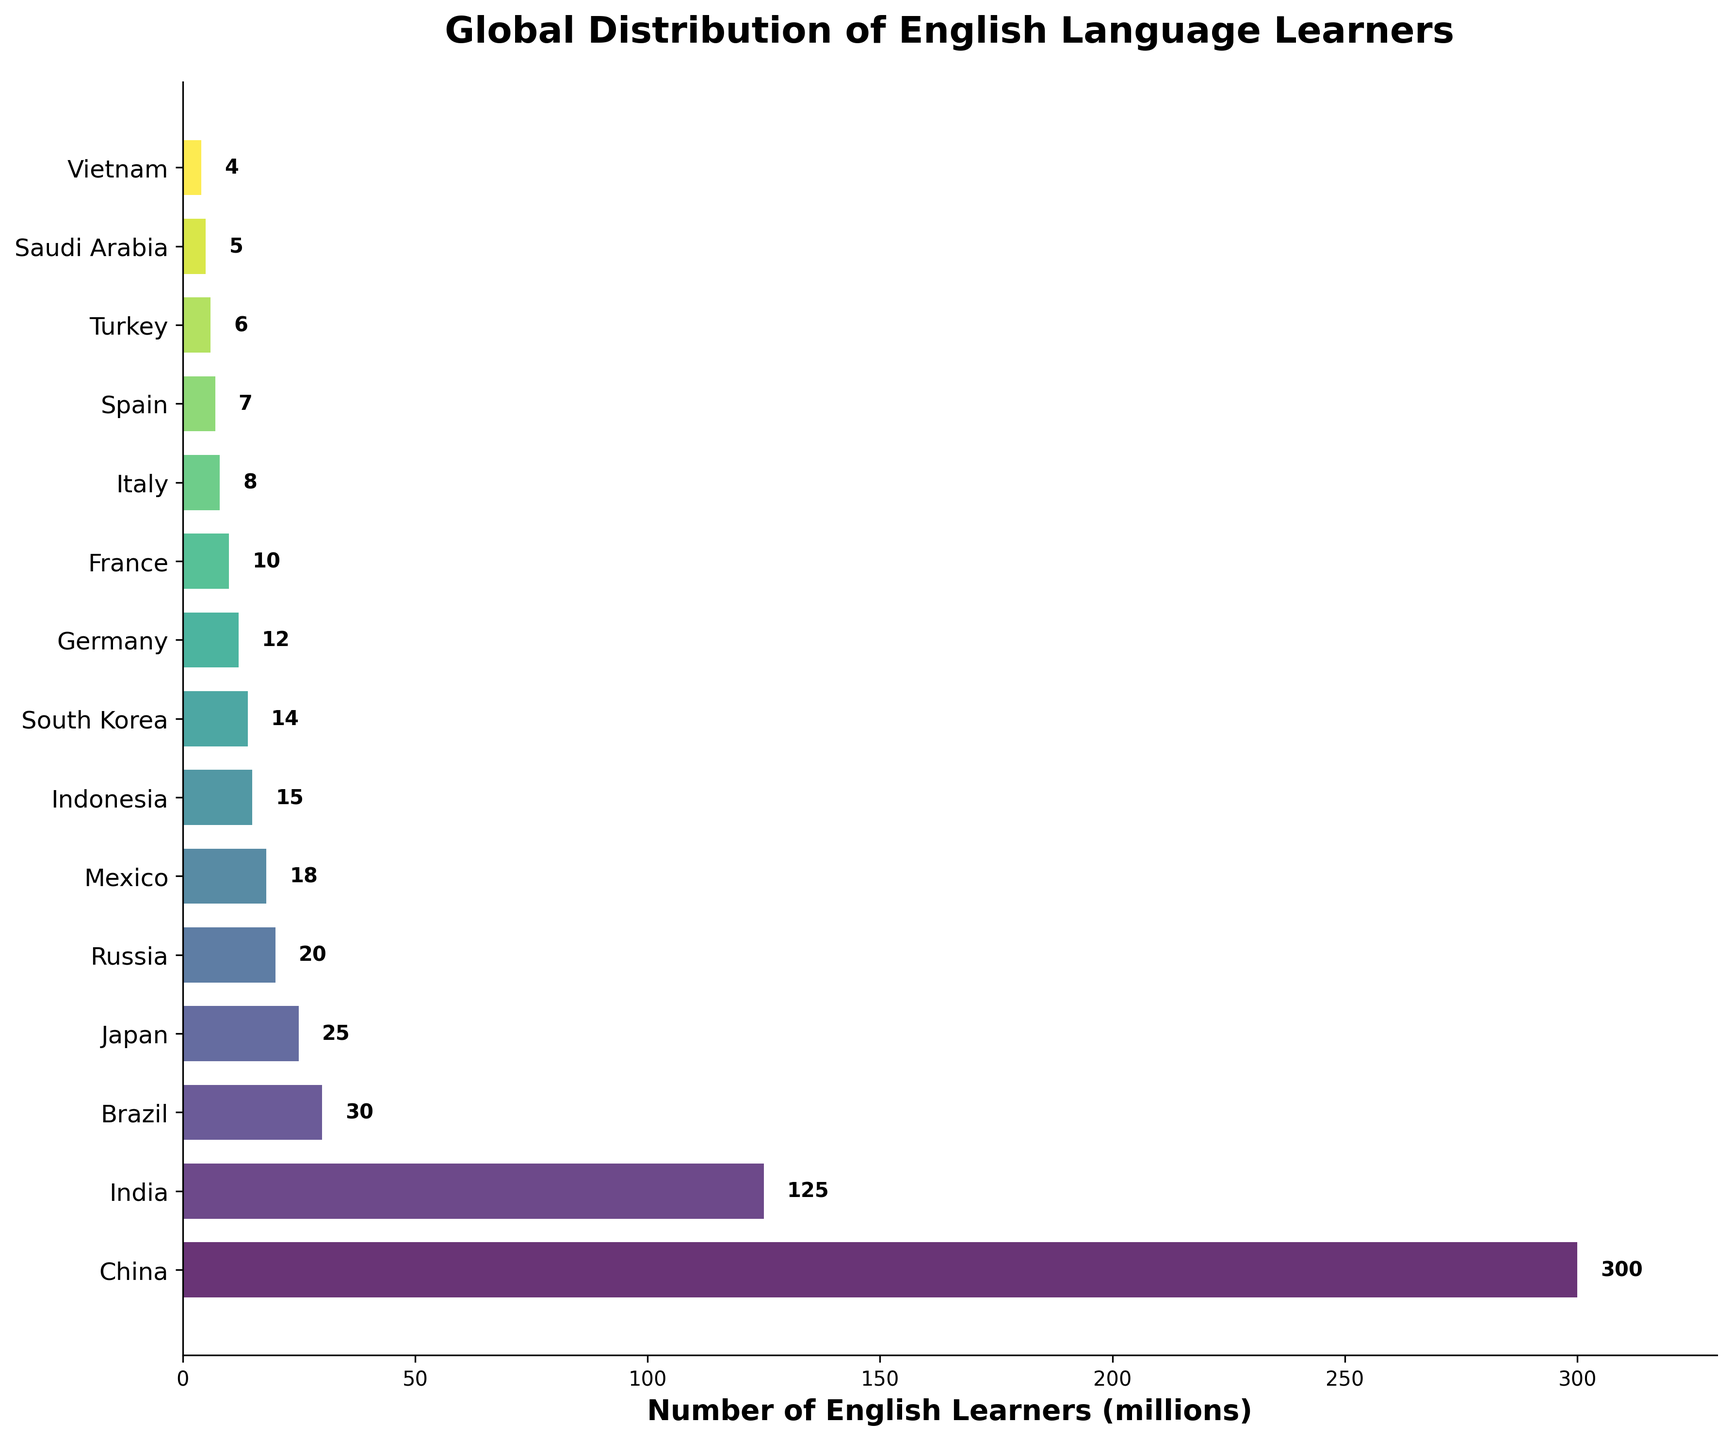Which country has the highest number of English learners? The figure shows bars representing each country with the number of English learners. The longest bar corresponds to China, which has 300 million English learners.
Answer: China How many countries have more than 50 million English learners? By inspecting the lengths of the bars, only China and India have bars that extend beyond 50 million learners.
Answer: 2 What is the total number of English learners in Russia and Japan? The bars for Russia and Japan have values of 20 million and 25 million, respectively. Adding these together gives 20 + 25 = 45 million.
Answer: 45 million Which country has fewer English learners: Spain or Turkey? Both Spain and Turkey's bars are shorter than some others, and by examining their endpoints, Spain has 7 million learners, whereas Turkey has 6 million. Therefore, Turkey has fewer learners than Spain.
Answer: Turkey What is the difference in the number of English learners between Brazil and Mexico? Brazil has a bar representing 30 million learners, whereas Mexico's bar shows 18 million. Subtracting these gives 30 - 18 = 12 million.
Answer: 12 million What is the sum of English learners in Indonesia, South Korea, and Germany? From the figure, Indonesia has 15 million learners, South Korea has 14 million, and Germany has 12 million. Adding these values gives 15 + 14 + 12 = 41 million.
Answer: 41 million How many countries have fewer than 10 million English learners? By inspecting the bars, France, Italy, Spain, Turkey, Saudi Arabia, and Vietnam each have fewer than 10 million learners, making a total of 6 countries.
Answer: 6 Which countries have bars with a similar height to Vietnam's? The bar representing Vietnam is at 4 million learners. The closest bars are Saudi Arabia at 5 million and none below 4 million.
Answer: Saudi Arabia What is the average number of English learners across all listed countries? Summing the number of learners for all countries gives 300 + 125 + 30 + 25 + 20 + 18 + 15 + 14 + 12 + 10 + 8 + 7 + 6 + 5 + 4 = 599 million. Dividing by the number of countries (15) gives an average of 599/15 ≈ 39.93 million.
Answer: 39.93 million 